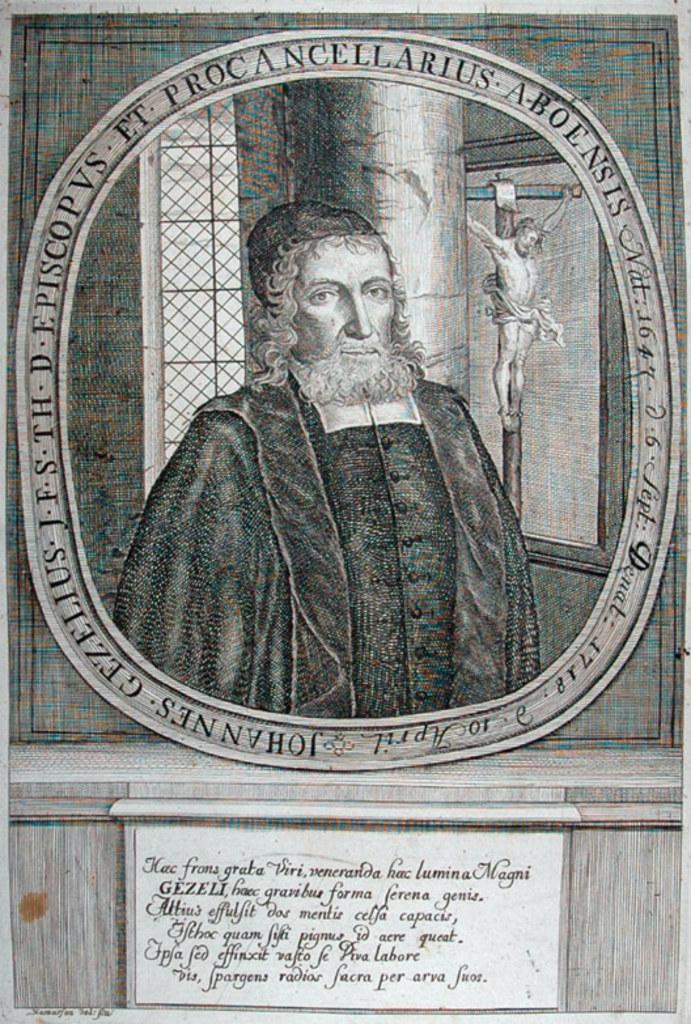What type of structure can be seen in the image? There is a wall in the image. What is located near the wall? There is a statue in the image. Can you describe the person in the image? There is a person wearing a black dress in the image. What type of animal is depicted in the statue in the image? There is no animal depicted in the statue in the image; it is a statue of a person. Is there a flame burning near the person in the image? There is no flame present in the image. 